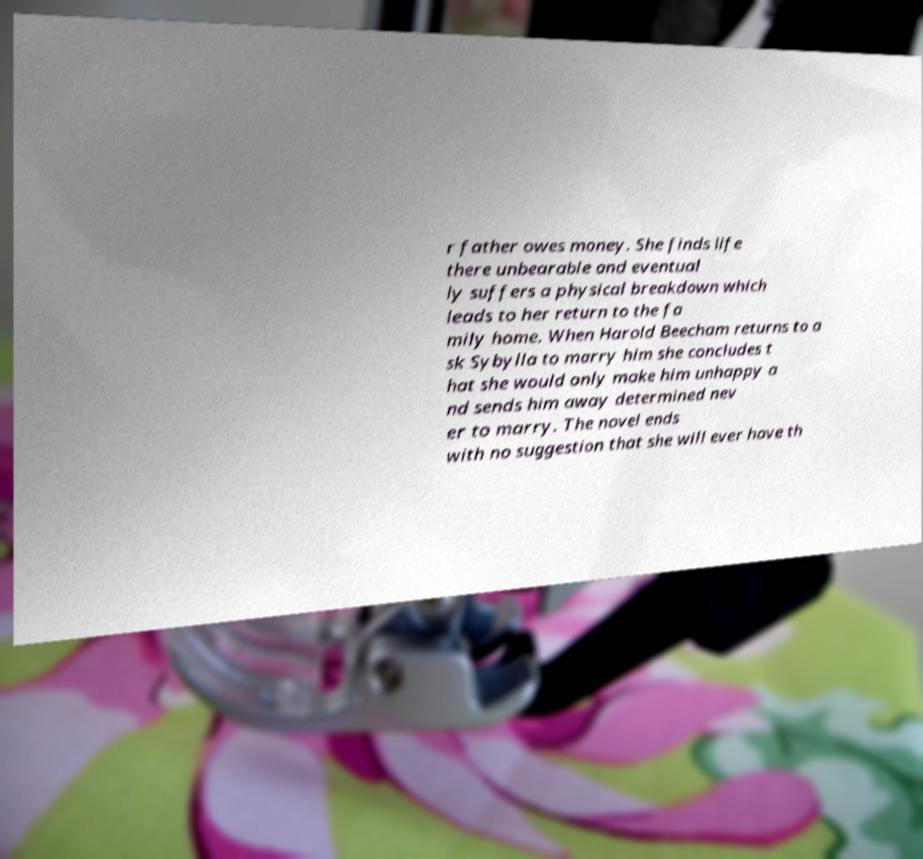There's text embedded in this image that I need extracted. Can you transcribe it verbatim? r father owes money. She finds life there unbearable and eventual ly suffers a physical breakdown which leads to her return to the fa mily home. When Harold Beecham returns to a sk Sybylla to marry him she concludes t hat she would only make him unhappy a nd sends him away determined nev er to marry. The novel ends with no suggestion that she will ever have th 